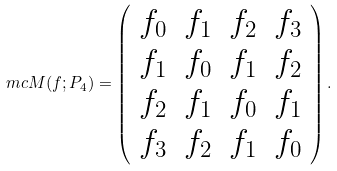Convert formula to latex. <formula><loc_0><loc_0><loc_500><loc_500>\ m c { M } ( f ; P _ { 4 } ) = \left ( \begin{array} { c c c c } f _ { 0 } & f _ { 1 } & f _ { 2 } & f _ { 3 } \\ f _ { 1 } & f _ { 0 } & f _ { 1 } & f _ { 2 } \\ f _ { 2 } & f _ { 1 } & f _ { 0 } & f _ { 1 } \\ f _ { 3 } & f _ { 2 } & f _ { 1 } & f _ { 0 } \end{array} \right ) .</formula> 